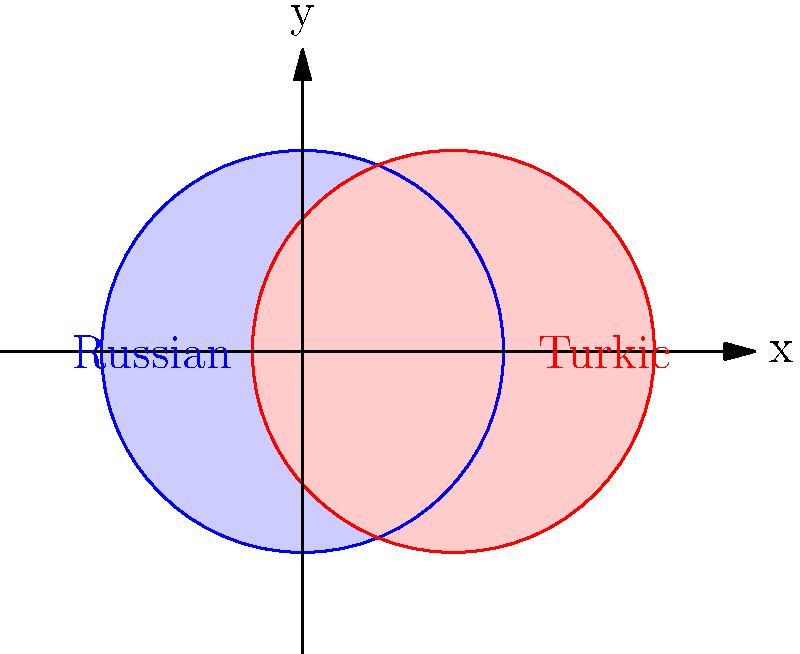In the diagram, two circles represent the linguistic features of Russian and Turkic languages. Each circle has a radius of 2 units, and their centers are 1.5 units apart on the x-axis. Calculate the area of the overlapping region, which symbolizes the intersection of Russian and Turkic linguistic features. Round your answer to two decimal places. To find the area of the overlapping region between two circles, we can follow these steps:

1) First, we need to calculate the distance between the centers of the circles:
   $d = 1.5$ units

2) The radius of each circle is $r = 2$ units

3) To find the overlapping area, we use the formula for the area of intersection of two circles:

   $A = 2r^2 \arccos(\frac{d}{2r}) - d\sqrt{r^2 - \frac{d^2}{4}}$

4) Let's substitute our values:

   $A = 2(2^2) \arccos(\frac{1.5}{2(2)}) - 1.5\sqrt{2^2 - \frac{1.5^2}{4}}$

5) Simplify:
   $A = 8 \arccos(\frac{3}{8}) - 1.5\sqrt{4 - \frac{9}{16}}$

6) Calculate:
   $A = 8 \arccos(0.375) - 1.5\sqrt{3.4375}$
   $A \approx 8(1.2096) - 1.5(1.8540)$
   $A \approx 9.6768 - 2.7810$
   $A \approx 6.8958$

7) Rounding to two decimal places:
   $A \approx 6.90$ square units

This area represents the extent of shared linguistic features between Russian and Turkic languages in this model.
Answer: 6.90 square units 